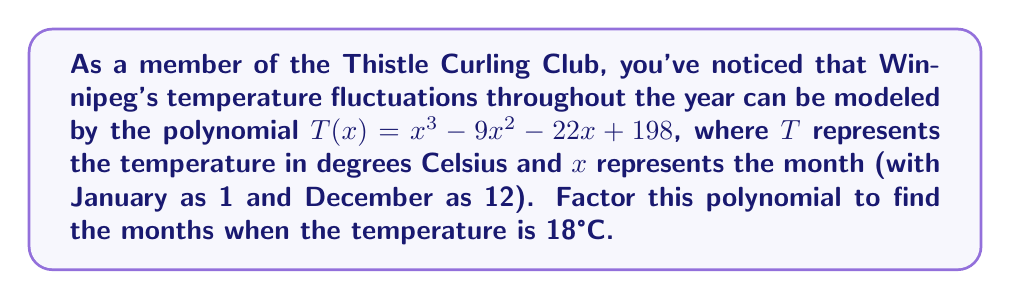Can you solve this math problem? Let's approach this step-by-step:

1) We need to factor the polynomial $T(x) = x^3 - 9x^2 - 22x + 198$.

2) First, we set $T(x) = 18$ because we want to find when the temperature is 18°C:

   $x^3 - 9x^2 - 22x + 198 = 18$

3) Subtract 18 from both sides:

   $x^3 - 9x^2 - 22x + 180 = 0$

4) This polynomial can be factored. Let's try to guess one factor. Given Winnipeg's climate, a reasonable guess might be $x = 6$ (June) or $x = 9$ (September). Let's try $x = 9$:

   $9^3 - 9(9^2) - 22(9) + 180 = 729 - 729 - 198 + 180 = -18$

   Close, but not zero. Let's try $x = 6$:

   $6^3 - 9(6^2) - 22(6) + 180 = 216 - 324 - 132 + 180 = -60$

5) $x - 6$ seems to be a factor. Let's use polynomial long division to find the other factors:

   $x^3 - 9x^2 - 22x + 180 = (x - 6)(x^2 - 3x - 30)$

6) The quadratic factor $x^2 - 3x - 30$ can be further factored:

   $x^2 - 3x - 30 = (x - 10)(x + 7)$

7) Therefore, the complete factorization is:

   $x^3 - 9x^2 - 22x + 180 = (x - 6)(x - 10)(x + 7)$

8) The roots of this polynomial are $x = 6$, $x = 10$, and $x = -7$. Since $x$ represents months, we can discard the negative solution.

9) Therefore, the temperature in Winnipeg is 18°C in June (month 6) and October (month 10).
Answer: $(x - 6)(x - 10)(x + 7)$; June and October 